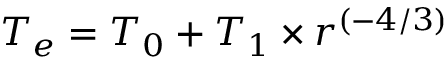<formula> <loc_0><loc_0><loc_500><loc_500>T _ { e } = T _ { 0 } + T _ { 1 } \times r ^ { ( - 4 / 3 ) }</formula> 